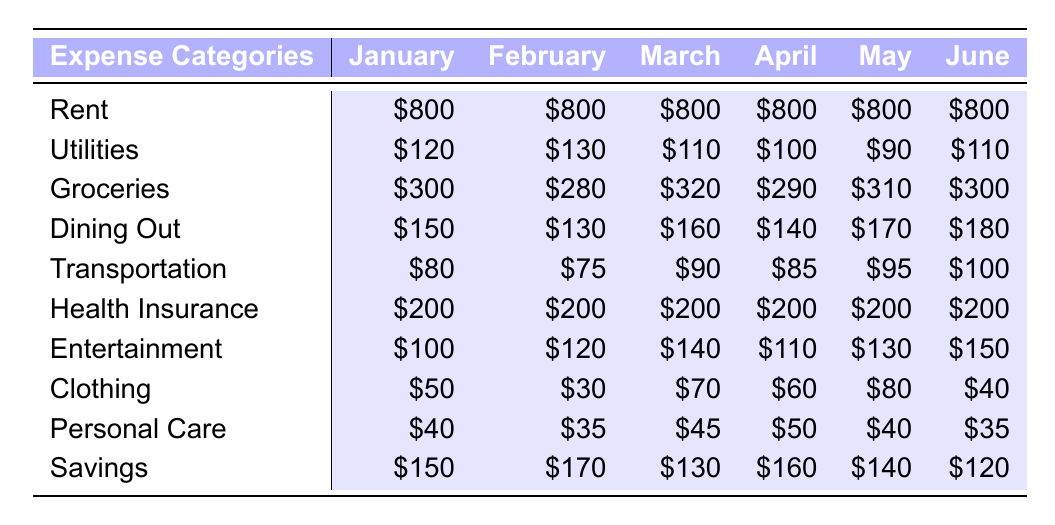What was the total expense for Dining Out in May? For May, the expense for Dining Out is listed as $170.
Answer: $170 What is the average cost of Utilities from January to June? The total for Utilities over the six months is (120 + 130 + 110 + 100 + 90 + 110) = 660. There are 6 months, so the average is 660 / 6 = 110.
Answer: $110 Did the expense for Groceries in March exceed that of January? In January, Groceries costs $300, while in March it costs $320, which is higher.
Answer: Yes What is the overall change in Transportation expenses from February to June? The expense in February is $75, while in June it is $100. The difference is 100 - 75 = 25.
Answer: $25 increase Which month had the highest expenditure on Entertainment, and what was the amount? Looking at the Entertainment expenses: January ($100), February ($120), March ($140), April ($110), May ($130), June ($150). June had the highest at $150.
Answer: June, $150 What is the total amount spent on Savings over the first six months? Adding the Savings amounts: (150 + 170 + 130 + 160 + 140 + 120) = 970.
Answer: $970 What was the percentage increase of Dining Out expenses from February to May? From February to May, the expenses went from $130 to $170. The increase is 170 - 130 = 40. The percentage increase is (40 / 130) * 100 = approximately 30.77%.
Answer: 30.77% How much more is spent on Rent compared to Personal Care in April? The Rent expense in April is $800 and the Personal Care expense is $50. The difference is 800 - 50 = 750.
Answer: $750 In which month were the total expenses the least? To determine this, we calculate the total expenses for each month: January = $800 + $120 + $300 + $150 + $80 + $200 + $100 + $50 + $40 + $150 = 1990, February = $800 + $130 + $280 + $130 + $75 + $200 + $120 + $30 + $35 + $170 = 1990, March = $800 + $110 + $320 + $160 + $90 + $200 + $140 + $70 + $45 + $130 = 2065, April = 1985, May = 1990, June = 2000. April had the least total expenses of $1985.
Answer: April Is there any month where the expense for Clothing dropped below $40? According to the expenses listed: January is $50, February is $30, March is $70, April is $60, May is $80, June is $40. February had Clothing expenses below $40.
Answer: Yes, February 